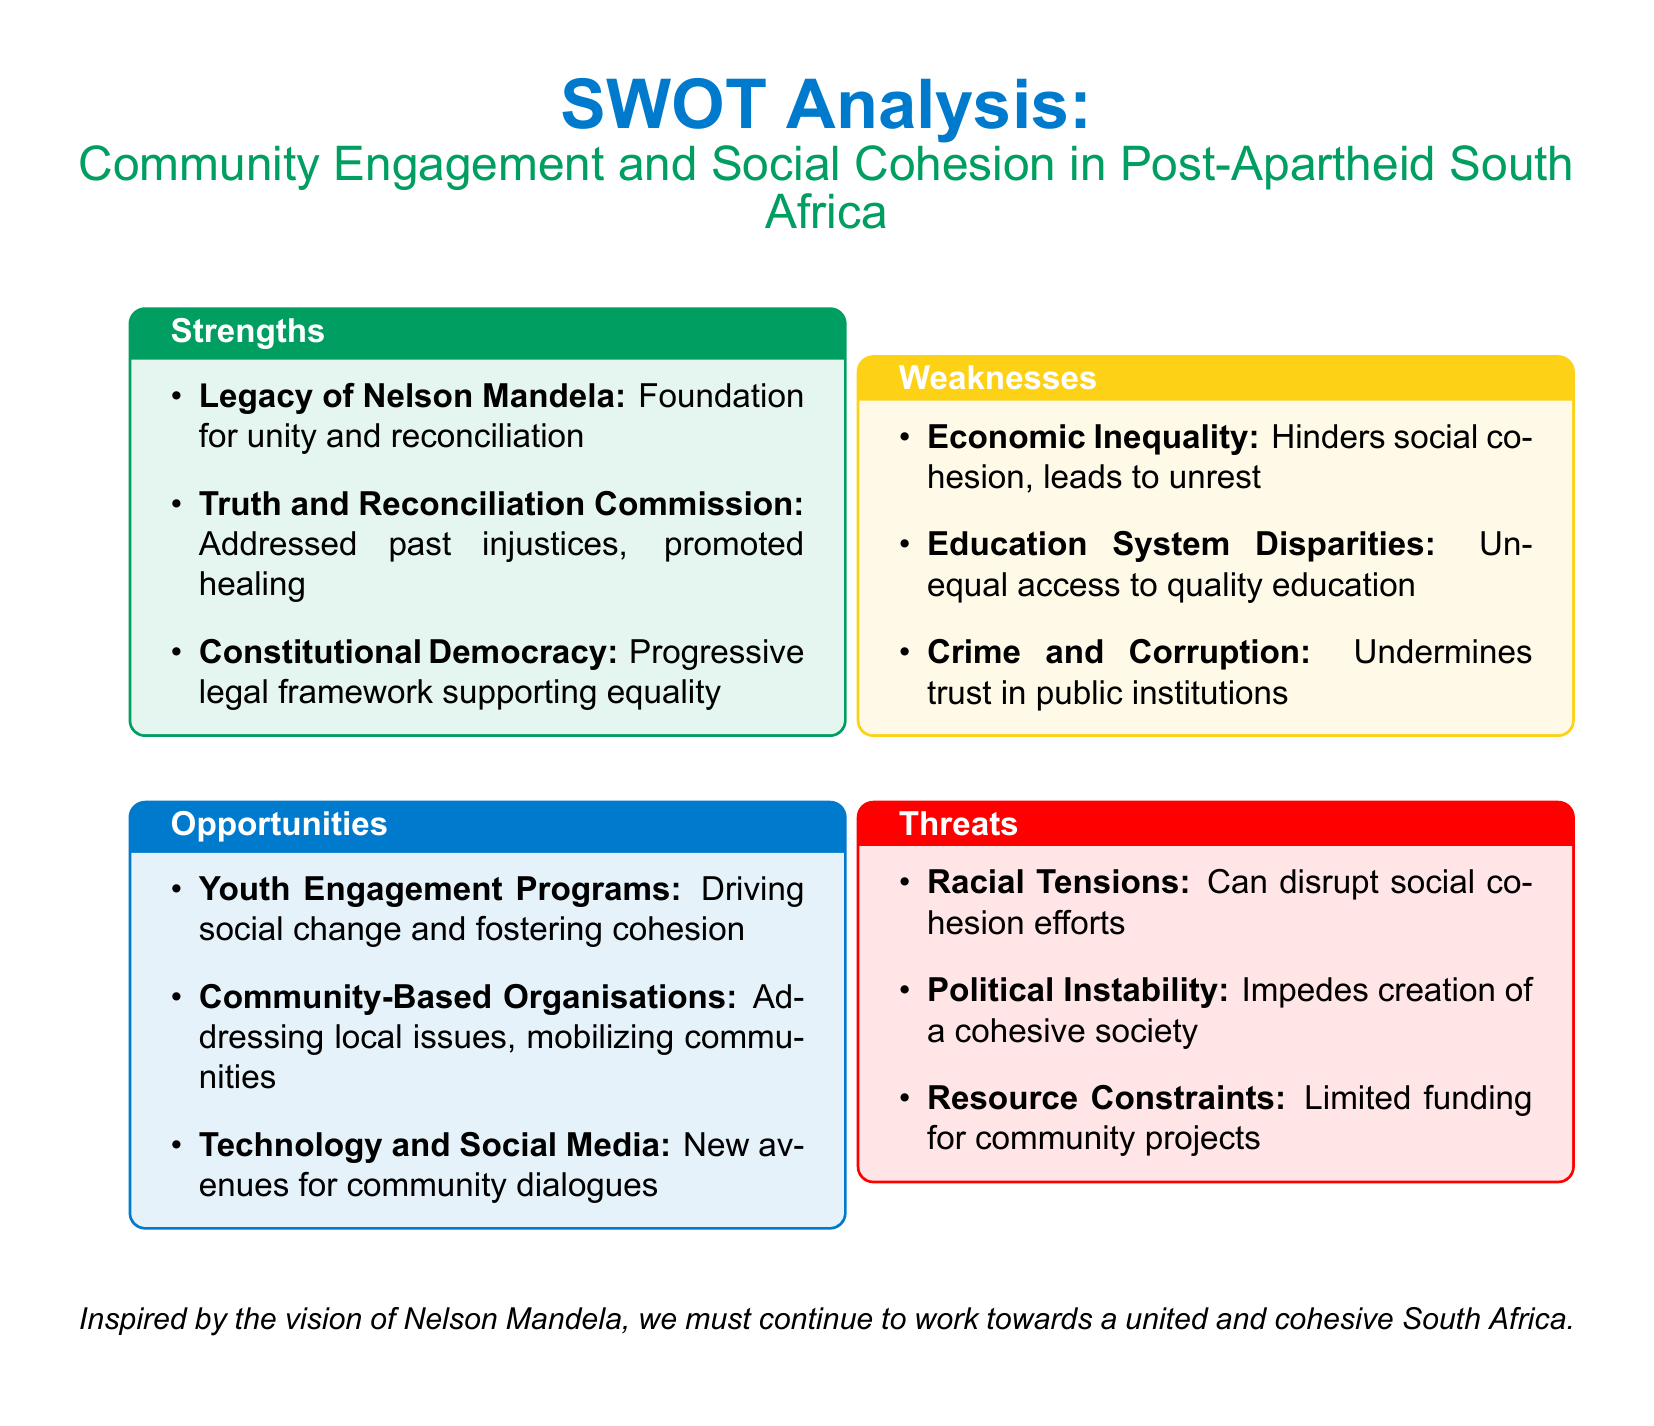what is a key strength in community engagement post-apartheid? The document lists the legacy of Nelson Mandela as a foundational strength for unity and reconciliation.
Answer: Legacy of Nelson Mandela what institution promoted healing after past injustices? The Truth and Reconciliation Commission is mentioned as a key institution that addressed injustices and promoted healing.
Answer: Truth and Reconciliation Commission which advantage focuses on future generations? The document mentions Youth Engagement Programs as an opportunity for driving social change and fostering cohesion.
Answer: Youth Engagement Programs what is a significant weakness mentioned in the analysis? Economic Inequality is highlighted as a weakness that hinders social cohesion.
Answer: Economic Inequality what type of tensions are identified as a threat to social cohesion? The document identifies Racial Tensions as a threat that can disrupt efforts toward social cohesion.
Answer: Racial Tensions what is a key opportunity provided by modern technology? The document states that Technology and Social Media create new avenues for community dialogues.
Answer: Technology and Social Media what main issue arises from disparities in the education system? The document states that unequal access to quality education is a key issue stemming from education system disparities.
Answer: Unequal access to quality education how does the document characterize the political environment as a challenge? The document refers to Political Instability as a factor that impedes the creation of a cohesive society.
Answer: Political Instability 